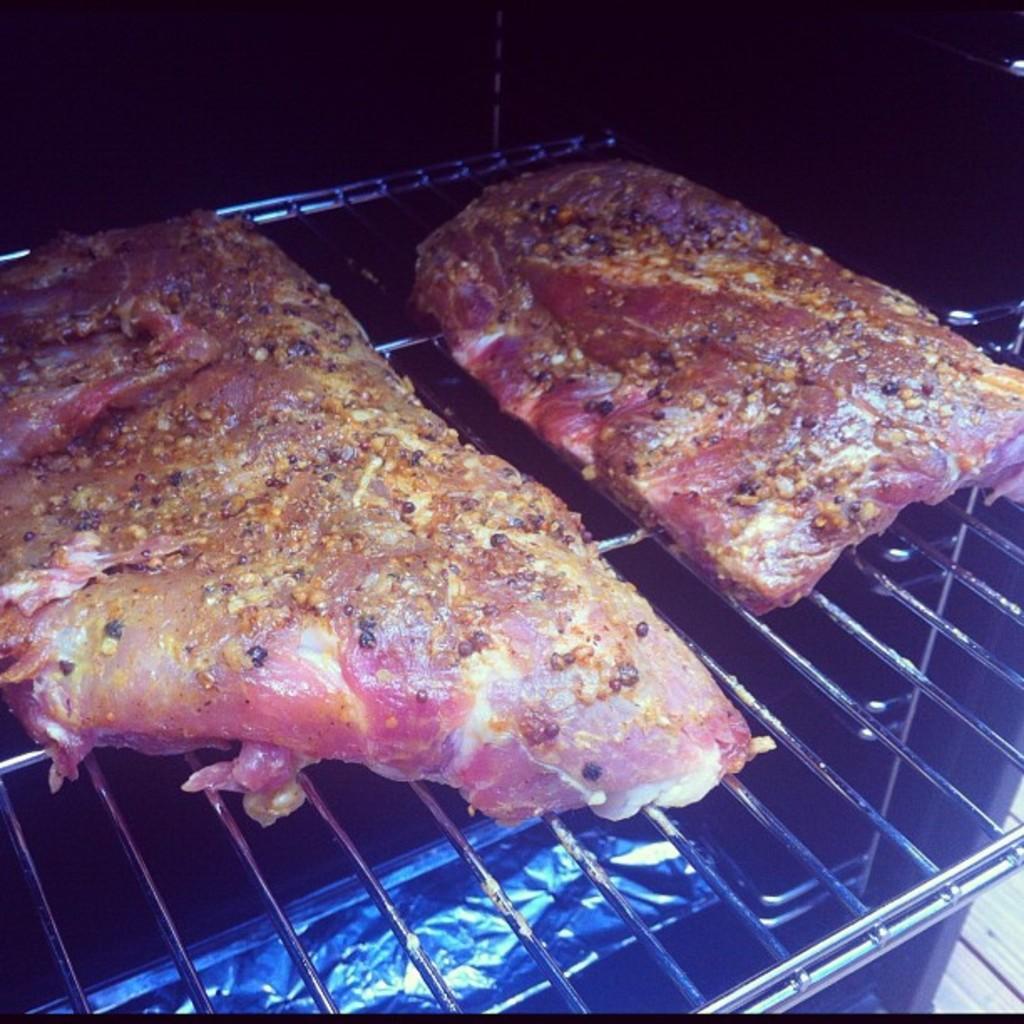Can you describe this image briefly? In this image we can see the meat on the grill. 